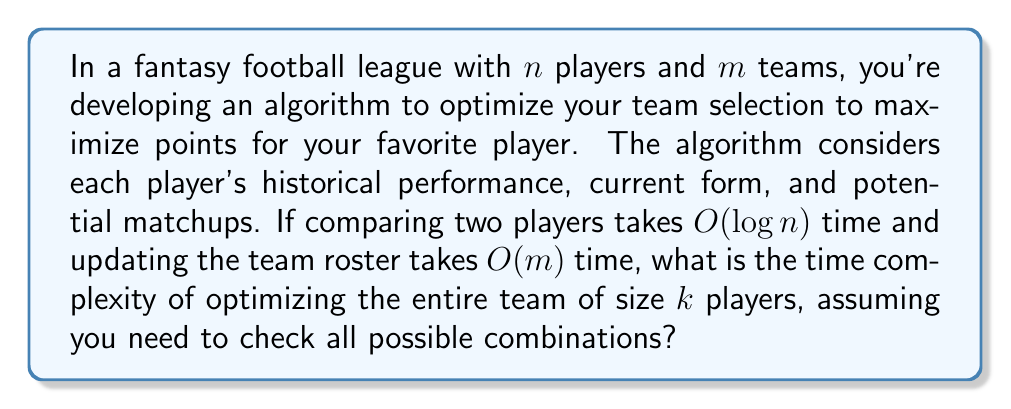Solve this math problem. Let's break this down step-by-step:

1) First, we need to consider the number of possible combinations. To select $k$ players out of $n$, we have $\binom{n}{k}$ combinations.

2) For each combination:
   a) We need to compare $k$ players, each taking $O(\log n)$ time.
   b) We need to update the team roster, taking $O(m)$ time.

3) Therefore, for each combination, we perform $O(k \log n + m)$ operations.

4) The total time complexity is thus:

   $$O(\binom{n}{k} \cdot (k \log n + m))$$

5) We know that $\binom{n}{k} \leq n^k$ for all $1 \leq k \leq n$. So we can upper bound our complexity:

   $$O(n^k \cdot (k \log n + m))$$

6) Expanding this:

   $$O(n^k \cdot k \log n + n^k \cdot m)$$

7) Since $k$ and $m$ are typically much smaller than $n$ in fantasy football scenarios, the dominant term will be $n^k \cdot k \log n$.

Therefore, the time complexity of the algorithm is $O(n^k \cdot k \log n)$.

This complexity shows why optimizing for your favorite player can be computationally intensive - it grows exponentially with the team size $k$, which explains why you might spend so much time perfecting your lineup to showcase your idol's greatness!
Answer: $O(n^k \cdot k \log n)$ 